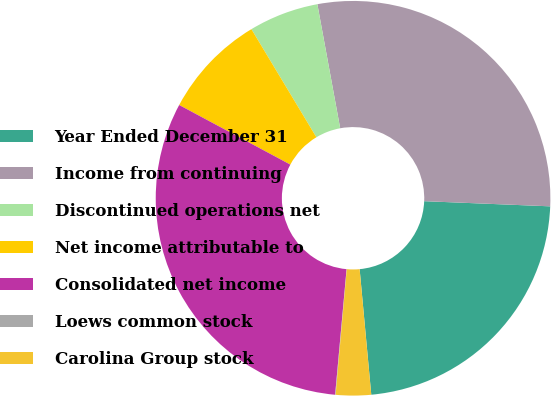Convert chart. <chart><loc_0><loc_0><loc_500><loc_500><pie_chart><fcel>Year Ended December 31<fcel>Income from continuing<fcel>Discontinued operations net<fcel>Net income attributable to<fcel>Consolidated net income<fcel>Loews common stock<fcel>Carolina Group stock<nl><fcel>22.88%<fcel>28.55%<fcel>5.72%<fcel>8.55%<fcel>31.39%<fcel>0.04%<fcel>2.88%<nl></chart> 